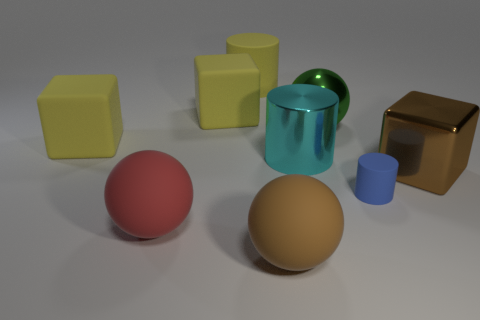What is the color of the large shiny cylinder?
Your response must be concise. Cyan. The thing that is the same color as the shiny cube is what size?
Your answer should be compact. Large. What number of green things are in front of the brown sphere?
Provide a short and direct response. 0. What is the size of the matte block that is to the left of the yellow block that is behind the big green ball?
Make the answer very short. Large. Does the big thing that is on the right side of the small object have the same shape as the large brown thing that is in front of the metallic block?
Keep it short and to the point. No. There is a big metallic thing that is behind the matte object that is left of the red thing; what shape is it?
Provide a short and direct response. Sphere. There is a thing that is both behind the small matte object and right of the green object; what size is it?
Your answer should be very brief. Large. Is the shape of the red matte thing the same as the big thing that is to the right of the blue matte thing?
Offer a terse response. No. There is a brown matte thing that is the same shape as the red object; what is its size?
Offer a very short reply. Large. There is a metal cube; is it the same color as the cylinder to the right of the cyan shiny object?
Offer a terse response. No. 